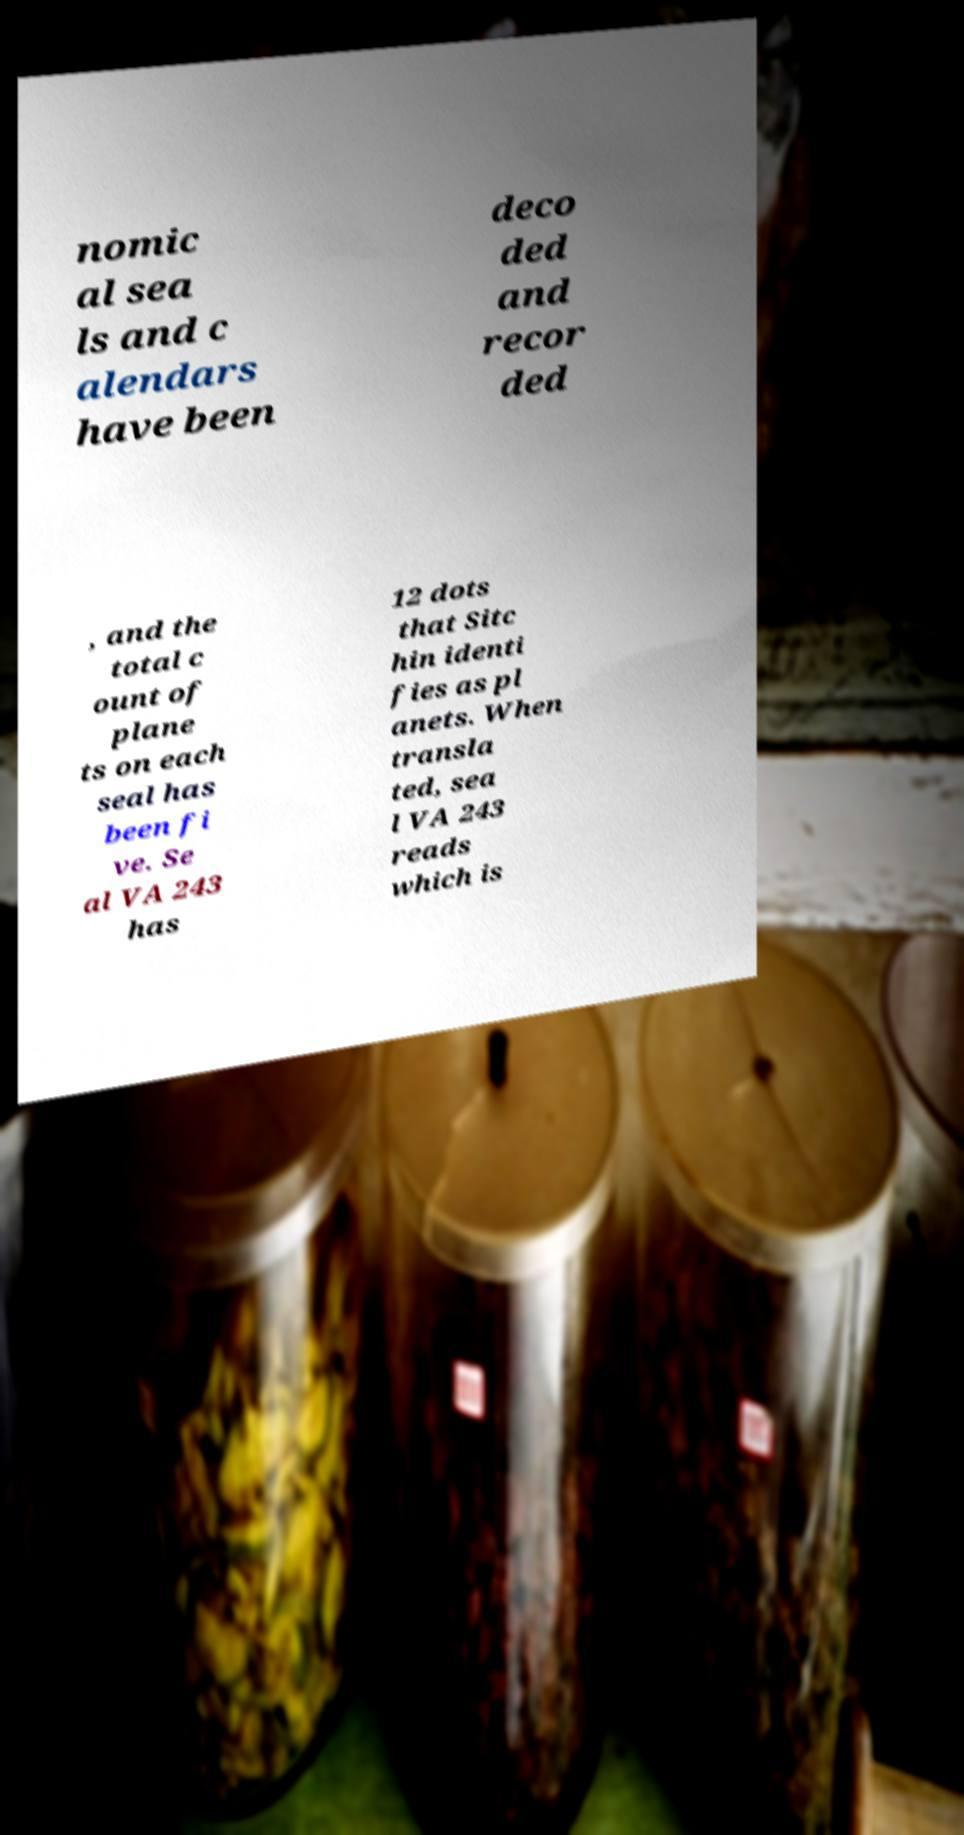What messages or text are displayed in this image? I need them in a readable, typed format. nomic al sea ls and c alendars have been deco ded and recor ded , and the total c ount of plane ts on each seal has been fi ve. Se al VA 243 has 12 dots that Sitc hin identi fies as pl anets. When transla ted, sea l VA 243 reads which is 